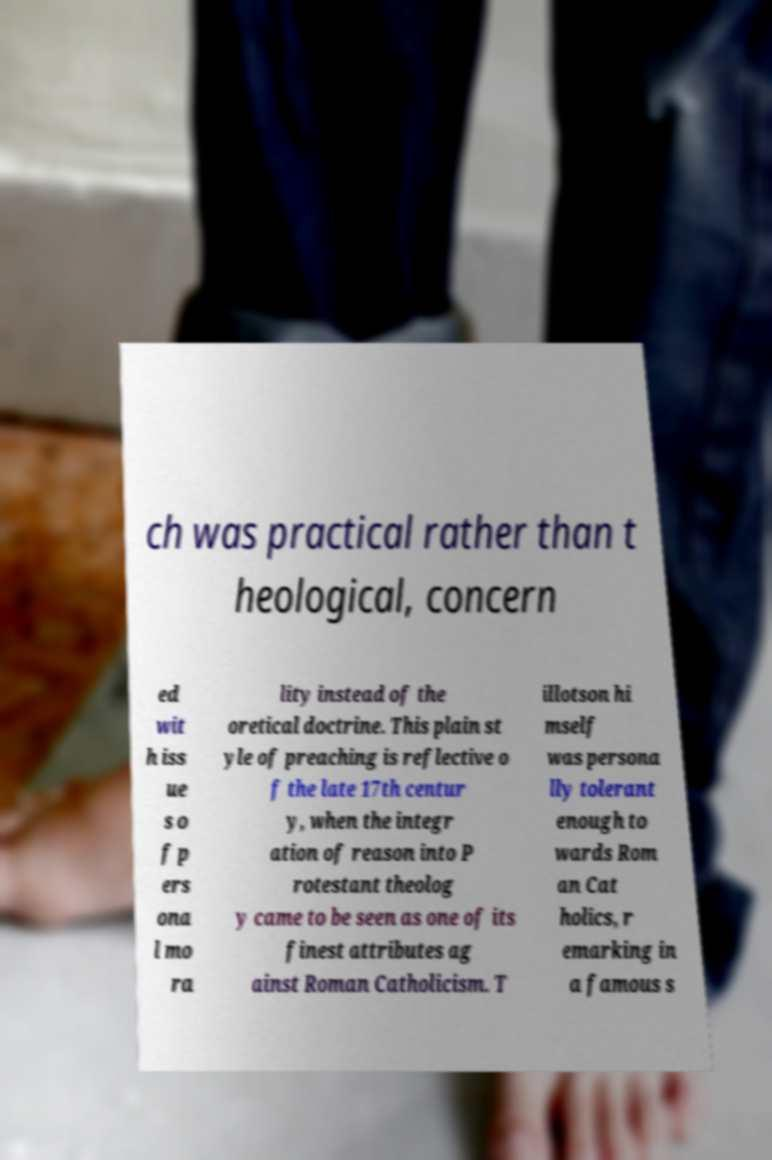There's text embedded in this image that I need extracted. Can you transcribe it verbatim? ch was practical rather than t heological, concern ed wit h iss ue s o f p ers ona l mo ra lity instead of the oretical doctrine. This plain st yle of preaching is reflective o f the late 17th centur y, when the integr ation of reason into P rotestant theolog y came to be seen as one of its finest attributes ag ainst Roman Catholicism. T illotson hi mself was persona lly tolerant enough to wards Rom an Cat holics, r emarking in a famous s 